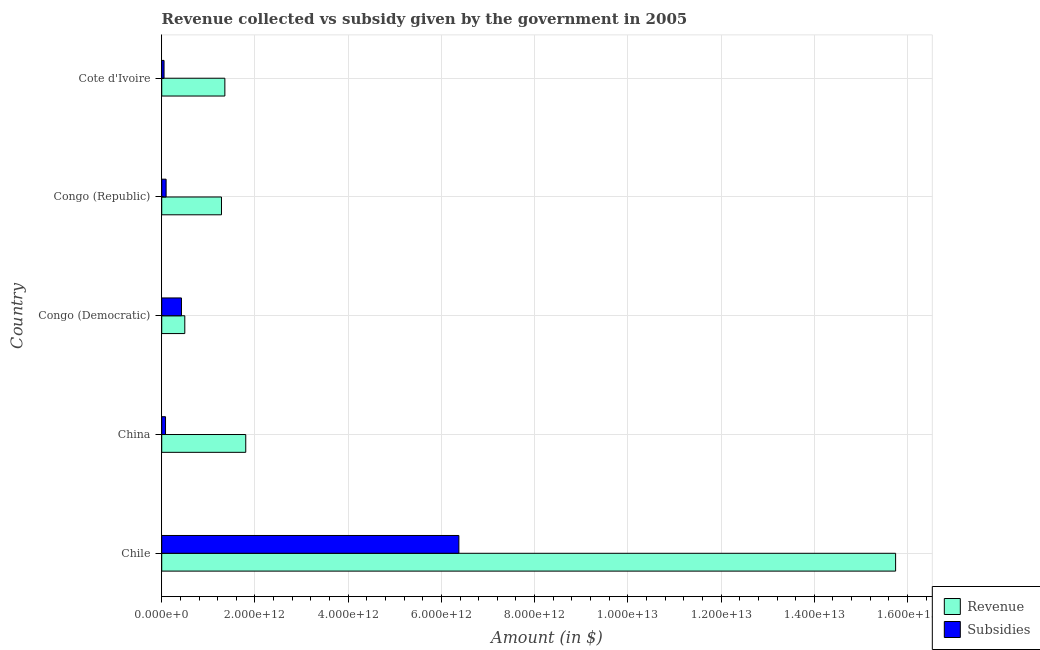How many different coloured bars are there?
Provide a short and direct response. 2. How many groups of bars are there?
Provide a short and direct response. 5. Are the number of bars per tick equal to the number of legend labels?
Your answer should be very brief. Yes. What is the label of the 2nd group of bars from the top?
Your answer should be very brief. Congo (Republic). What is the amount of revenue collected in Congo (Republic)?
Provide a short and direct response. 1.28e+12. Across all countries, what is the maximum amount of subsidies given?
Give a very brief answer. 6.38e+12. Across all countries, what is the minimum amount of subsidies given?
Keep it short and to the point. 5.00e+1. In which country was the amount of subsidies given maximum?
Offer a very short reply. Chile. In which country was the amount of revenue collected minimum?
Offer a terse response. Congo (Democratic). What is the total amount of subsidies given in the graph?
Ensure brevity in your answer.  7.03e+12. What is the difference between the amount of subsidies given in Chile and that in Congo (Democratic)?
Your response must be concise. 5.95e+12. What is the difference between the amount of subsidies given in Cote d'Ivoire and the amount of revenue collected in Chile?
Make the answer very short. -1.57e+13. What is the average amount of subsidies given per country?
Your answer should be compact. 1.41e+12. What is the difference between the amount of subsidies given and amount of revenue collected in Cote d'Ivoire?
Keep it short and to the point. -1.30e+12. What is the ratio of the amount of subsidies given in Chile to that in Congo (Democratic)?
Make the answer very short. 15.04. Is the amount of revenue collected in China less than that in Congo (Republic)?
Keep it short and to the point. No. What is the difference between the highest and the second highest amount of subsidies given?
Offer a terse response. 5.95e+12. What is the difference between the highest and the lowest amount of revenue collected?
Ensure brevity in your answer.  1.52e+13. Is the sum of the amount of revenue collected in Congo (Republic) and Cote d'Ivoire greater than the maximum amount of subsidies given across all countries?
Provide a succinct answer. No. What does the 2nd bar from the top in Congo (Republic) represents?
Your answer should be very brief. Revenue. What does the 1st bar from the bottom in Congo (Democratic) represents?
Offer a very short reply. Revenue. How many bars are there?
Keep it short and to the point. 10. What is the difference between two consecutive major ticks on the X-axis?
Keep it short and to the point. 2.00e+12. Does the graph contain any zero values?
Ensure brevity in your answer.  No. Does the graph contain grids?
Your response must be concise. Yes. Where does the legend appear in the graph?
Make the answer very short. Bottom right. How are the legend labels stacked?
Ensure brevity in your answer.  Vertical. What is the title of the graph?
Your answer should be compact. Revenue collected vs subsidy given by the government in 2005. What is the label or title of the X-axis?
Your answer should be very brief. Amount (in $). What is the Amount (in $) in Revenue in Chile?
Provide a short and direct response. 1.57e+13. What is the Amount (in $) of Subsidies in Chile?
Provide a short and direct response. 6.38e+12. What is the Amount (in $) in Revenue in China?
Make the answer very short. 1.80e+12. What is the Amount (in $) in Subsidies in China?
Make the answer very short. 8.19e+1. What is the Amount (in $) in Revenue in Congo (Democratic)?
Offer a very short reply. 4.95e+11. What is the Amount (in $) in Subsidies in Congo (Democratic)?
Make the answer very short. 4.24e+11. What is the Amount (in $) of Revenue in Congo (Republic)?
Provide a short and direct response. 1.28e+12. What is the Amount (in $) of Subsidies in Congo (Republic)?
Provide a short and direct response. 9.43e+1. What is the Amount (in $) in Revenue in Cote d'Ivoire?
Offer a very short reply. 1.35e+12. What is the Amount (in $) of Subsidies in Cote d'Ivoire?
Your response must be concise. 5.00e+1. Across all countries, what is the maximum Amount (in $) in Revenue?
Your response must be concise. 1.57e+13. Across all countries, what is the maximum Amount (in $) of Subsidies?
Your answer should be compact. 6.38e+12. Across all countries, what is the minimum Amount (in $) in Revenue?
Offer a very short reply. 4.95e+11. Across all countries, what is the minimum Amount (in $) in Subsidies?
Give a very brief answer. 5.00e+1. What is the total Amount (in $) of Revenue in the graph?
Your response must be concise. 2.07e+13. What is the total Amount (in $) of Subsidies in the graph?
Offer a very short reply. 7.03e+12. What is the difference between the Amount (in $) in Revenue in Chile and that in China?
Your response must be concise. 1.39e+13. What is the difference between the Amount (in $) in Subsidies in Chile and that in China?
Provide a short and direct response. 6.29e+12. What is the difference between the Amount (in $) of Revenue in Chile and that in Congo (Democratic)?
Keep it short and to the point. 1.52e+13. What is the difference between the Amount (in $) of Subsidies in Chile and that in Congo (Democratic)?
Offer a very short reply. 5.95e+12. What is the difference between the Amount (in $) in Revenue in Chile and that in Congo (Republic)?
Provide a short and direct response. 1.45e+13. What is the difference between the Amount (in $) of Subsidies in Chile and that in Congo (Republic)?
Your answer should be compact. 6.28e+12. What is the difference between the Amount (in $) in Revenue in Chile and that in Cote d'Ivoire?
Make the answer very short. 1.44e+13. What is the difference between the Amount (in $) in Subsidies in Chile and that in Cote d'Ivoire?
Offer a very short reply. 6.33e+12. What is the difference between the Amount (in $) of Revenue in China and that in Congo (Democratic)?
Provide a short and direct response. 1.31e+12. What is the difference between the Amount (in $) in Subsidies in China and that in Congo (Democratic)?
Your answer should be very brief. -3.42e+11. What is the difference between the Amount (in $) of Revenue in China and that in Congo (Republic)?
Provide a short and direct response. 5.21e+11. What is the difference between the Amount (in $) in Subsidies in China and that in Congo (Republic)?
Your response must be concise. -1.24e+1. What is the difference between the Amount (in $) in Revenue in China and that in Cote d'Ivoire?
Your answer should be compact. 4.48e+11. What is the difference between the Amount (in $) in Subsidies in China and that in Cote d'Ivoire?
Your answer should be very brief. 3.19e+1. What is the difference between the Amount (in $) of Revenue in Congo (Democratic) and that in Congo (Republic)?
Give a very brief answer. -7.87e+11. What is the difference between the Amount (in $) of Subsidies in Congo (Democratic) and that in Congo (Republic)?
Your answer should be compact. 3.30e+11. What is the difference between the Amount (in $) in Revenue in Congo (Democratic) and that in Cote d'Ivoire?
Provide a short and direct response. -8.59e+11. What is the difference between the Amount (in $) in Subsidies in Congo (Democratic) and that in Cote d'Ivoire?
Your response must be concise. 3.74e+11. What is the difference between the Amount (in $) of Revenue in Congo (Republic) and that in Cote d'Ivoire?
Keep it short and to the point. -7.23e+1. What is the difference between the Amount (in $) in Subsidies in Congo (Republic) and that in Cote d'Ivoire?
Ensure brevity in your answer.  4.43e+1. What is the difference between the Amount (in $) of Revenue in Chile and the Amount (in $) of Subsidies in China?
Your response must be concise. 1.57e+13. What is the difference between the Amount (in $) of Revenue in Chile and the Amount (in $) of Subsidies in Congo (Democratic)?
Your answer should be very brief. 1.53e+13. What is the difference between the Amount (in $) of Revenue in Chile and the Amount (in $) of Subsidies in Congo (Republic)?
Offer a terse response. 1.56e+13. What is the difference between the Amount (in $) of Revenue in Chile and the Amount (in $) of Subsidies in Cote d'Ivoire?
Your response must be concise. 1.57e+13. What is the difference between the Amount (in $) of Revenue in China and the Amount (in $) of Subsidies in Congo (Democratic)?
Your answer should be compact. 1.38e+12. What is the difference between the Amount (in $) of Revenue in China and the Amount (in $) of Subsidies in Congo (Republic)?
Your answer should be compact. 1.71e+12. What is the difference between the Amount (in $) in Revenue in China and the Amount (in $) in Subsidies in Cote d'Ivoire?
Provide a succinct answer. 1.75e+12. What is the difference between the Amount (in $) in Revenue in Congo (Democratic) and the Amount (in $) in Subsidies in Congo (Republic)?
Provide a short and direct response. 4.01e+11. What is the difference between the Amount (in $) of Revenue in Congo (Democratic) and the Amount (in $) of Subsidies in Cote d'Ivoire?
Offer a very short reply. 4.45e+11. What is the difference between the Amount (in $) of Revenue in Congo (Republic) and the Amount (in $) of Subsidies in Cote d'Ivoire?
Give a very brief answer. 1.23e+12. What is the average Amount (in $) of Revenue per country?
Offer a terse response. 4.14e+12. What is the average Amount (in $) in Subsidies per country?
Ensure brevity in your answer.  1.41e+12. What is the difference between the Amount (in $) in Revenue and Amount (in $) in Subsidies in Chile?
Give a very brief answer. 9.37e+12. What is the difference between the Amount (in $) in Revenue and Amount (in $) in Subsidies in China?
Your response must be concise. 1.72e+12. What is the difference between the Amount (in $) in Revenue and Amount (in $) in Subsidies in Congo (Democratic)?
Give a very brief answer. 7.14e+1. What is the difference between the Amount (in $) of Revenue and Amount (in $) of Subsidies in Congo (Republic)?
Keep it short and to the point. 1.19e+12. What is the difference between the Amount (in $) of Revenue and Amount (in $) of Subsidies in Cote d'Ivoire?
Offer a very short reply. 1.30e+12. What is the ratio of the Amount (in $) in Revenue in Chile to that in China?
Your answer should be compact. 8.73. What is the ratio of the Amount (in $) of Subsidies in Chile to that in China?
Keep it short and to the point. 77.85. What is the ratio of the Amount (in $) of Revenue in Chile to that in Congo (Democratic)?
Provide a succinct answer. 31.79. What is the ratio of the Amount (in $) in Subsidies in Chile to that in Congo (Democratic)?
Keep it short and to the point. 15.04. What is the ratio of the Amount (in $) of Revenue in Chile to that in Congo (Republic)?
Offer a very short reply. 12.28. What is the ratio of the Amount (in $) of Subsidies in Chile to that in Congo (Republic)?
Keep it short and to the point. 67.6. What is the ratio of the Amount (in $) of Revenue in Chile to that in Cote d'Ivoire?
Provide a short and direct response. 11.62. What is the ratio of the Amount (in $) of Subsidies in Chile to that in Cote d'Ivoire?
Provide a short and direct response. 127.53. What is the ratio of the Amount (in $) of Revenue in China to that in Congo (Democratic)?
Offer a very short reply. 3.64. What is the ratio of the Amount (in $) of Subsidies in China to that in Congo (Democratic)?
Offer a terse response. 0.19. What is the ratio of the Amount (in $) of Revenue in China to that in Congo (Republic)?
Give a very brief answer. 1.41. What is the ratio of the Amount (in $) in Subsidies in China to that in Congo (Republic)?
Offer a terse response. 0.87. What is the ratio of the Amount (in $) in Revenue in China to that in Cote d'Ivoire?
Provide a succinct answer. 1.33. What is the ratio of the Amount (in $) in Subsidies in China to that in Cote d'Ivoire?
Give a very brief answer. 1.64. What is the ratio of the Amount (in $) of Revenue in Congo (Democratic) to that in Congo (Republic)?
Your answer should be compact. 0.39. What is the ratio of the Amount (in $) of Subsidies in Congo (Democratic) to that in Congo (Republic)?
Your answer should be very brief. 4.49. What is the ratio of the Amount (in $) of Revenue in Congo (Democratic) to that in Cote d'Ivoire?
Offer a very short reply. 0.37. What is the ratio of the Amount (in $) of Subsidies in Congo (Democratic) to that in Cote d'Ivoire?
Offer a terse response. 8.48. What is the ratio of the Amount (in $) in Revenue in Congo (Republic) to that in Cote d'Ivoire?
Your answer should be compact. 0.95. What is the ratio of the Amount (in $) of Subsidies in Congo (Republic) to that in Cote d'Ivoire?
Give a very brief answer. 1.89. What is the difference between the highest and the second highest Amount (in $) in Revenue?
Make the answer very short. 1.39e+13. What is the difference between the highest and the second highest Amount (in $) in Subsidies?
Provide a short and direct response. 5.95e+12. What is the difference between the highest and the lowest Amount (in $) of Revenue?
Ensure brevity in your answer.  1.52e+13. What is the difference between the highest and the lowest Amount (in $) of Subsidies?
Give a very brief answer. 6.33e+12. 